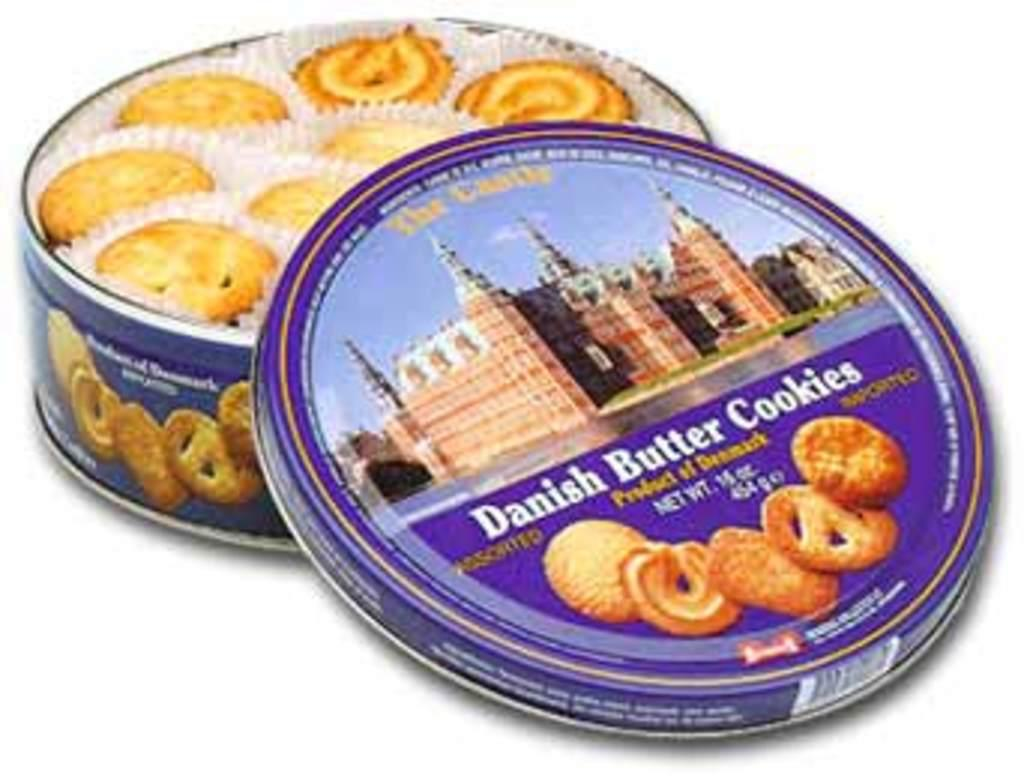What is the main object in the image? There is a box in the image. What is inside the box? The box is full of cookies. Can you describe the appearance of the box? There is text and design on the cap of the box. What color is the bone sticking out of the box in the image? There is no bone present in the image; it features a box full of cookies with text and design on the cap. 